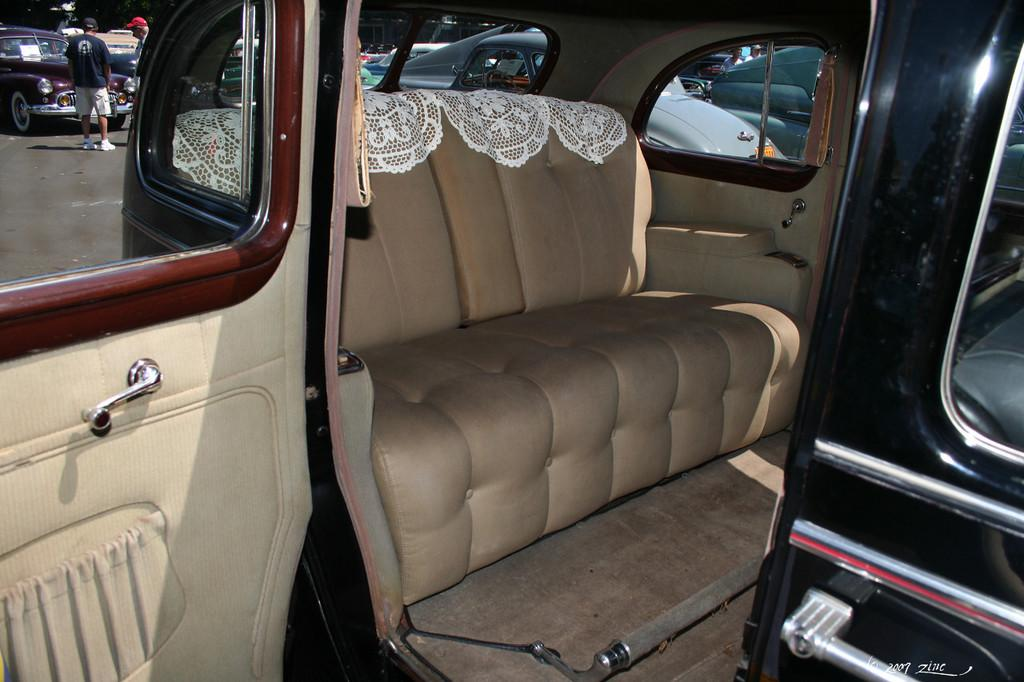What can be seen on the road in the image? There are cars parked on the road in the image. What else is visible near the parked cars? There are people standing near the parked cars in the image. What is the name of the feather that is visible in the image? There is no feather present in the image. How many friends are visible in the image? The provided facts do not mention friends, only people standing near the parked cars. 